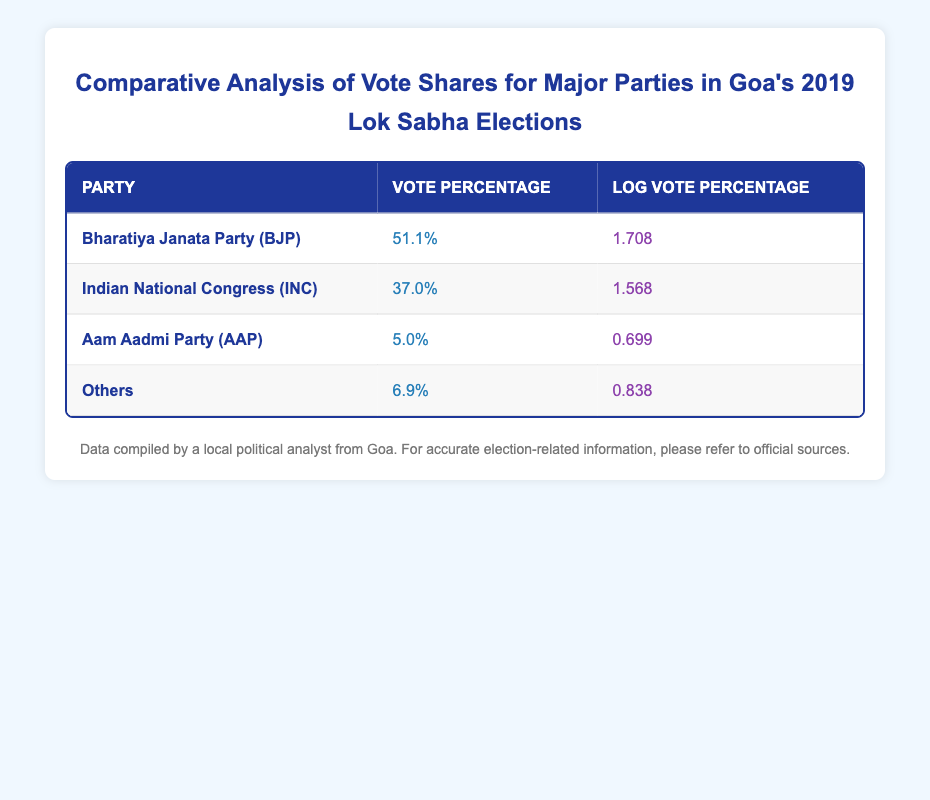What is the vote percentage of the Bharatiya Janata Party? The table shows the vote percentage for the Bharatiya Janata Party (BJP) as 51.1%.
Answer: 51.1% Which party received the lowest vote percentage? By comparing the vote percentages listed in the table, the Aam Aadmi Party (AAP) received the lowest vote percentage at 5.0%.
Answer: Aam Aadmi Party (AAP) What is the difference in vote percentage between BJP and INC? The vote percentage of BJP is 51.1% and that of INC is 37.0%. The difference is calculated as 51.1% - 37.0% = 14.1%.
Answer: 14.1% Is the log vote percentage of the Indian National Congress greater than that of the Others? The log vote percentage for the Indian National Congress (INC) is 1.568, while for Others it is 0.838. Since 1.568 is greater than 0.838, the statement is true.
Answer: Yes What is the total vote percentage for all parties listed in the table? The total vote percentage can be calculated by adding the individual percentages: 51.1% (BJP) + 37.0% (INC) + 5.0% (AAP) + 6.9% (Others) = 100%.
Answer: 100% Which party has the highest log vote percentage, and what is that value? The table indicates that the Bharatiya Janata Party (BJP) has the highest log vote percentage at 1.708.
Answer: Bharatiya Janata Party (BJP), 1.708 What is the average log vote percentage of INC and Others? The log vote percentages are 1.568 (INC) and 0.838 (Others). To find the average, add these values: 1.568 + 0.838 = 2.406, then divide by 2, giving 2.406 / 2 = 1.203.
Answer: 1.203 Does Aam Aadmi Party have more than 10% of the vote share? The table shows that Aam Aadmi Party (AAP) has a vote percentage of 5.0%, which is less than 10%. Therefore, the statement is false.
Answer: No What is the combined vote percentage of AAP and Others? The vote percentage of AAP is 5.0% and for Others it is 6.9%. Adding these gives 5.0% + 6.9% = 11.9%.
Answer: 11.9% 